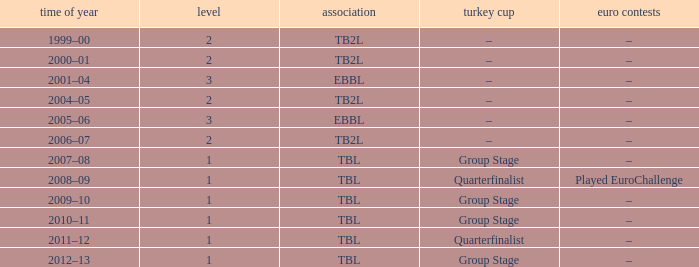Which league was the 2012-13 season a part of? TBL. 